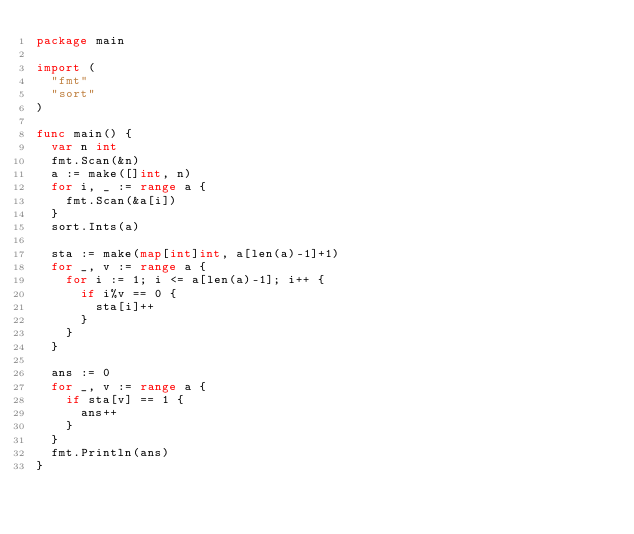<code> <loc_0><loc_0><loc_500><loc_500><_Go_>package main

import (
	"fmt"
	"sort"
)

func main() {
	var n int
	fmt.Scan(&n)
	a := make([]int, n)
	for i, _ := range a {
		fmt.Scan(&a[i])
	}
	sort.Ints(a)

	sta := make(map[int]int, a[len(a)-1]+1)
	for _, v := range a {
		for i := 1; i <= a[len(a)-1]; i++ {
			if i%v == 0 {
				sta[i]++
			}
		}
	}

	ans := 0
	for _, v := range a {
		if sta[v] == 1 {
			ans++
		}
	}
	fmt.Println(ans)
}</code> 